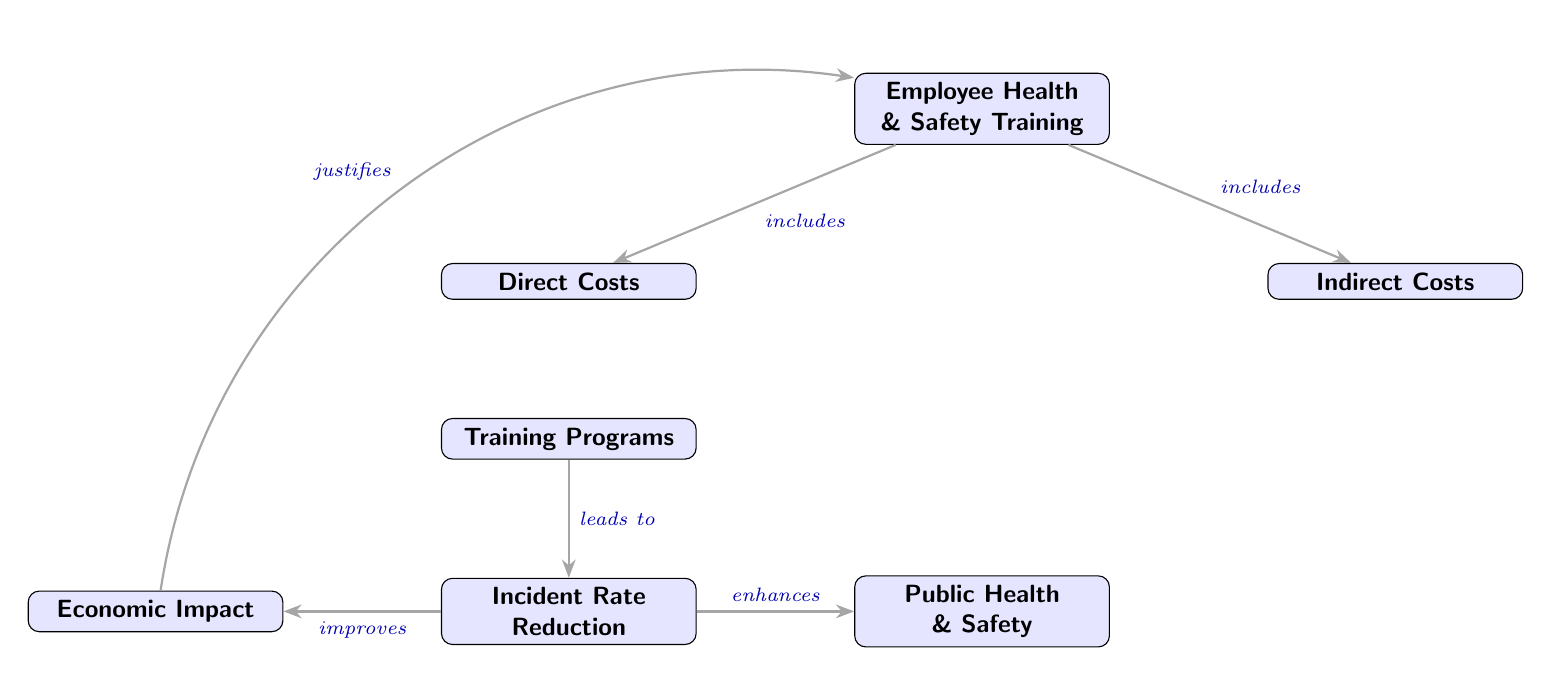What is the first node in the diagram? The first node in the diagram is labeled "Employee Health & Safety Training." This is the starting point from which all other elements are connected.
Answer: Employee Health & Safety Training How many total nodes are there in the diagram? By counting each distinct box within the diagram, we see there are seven nodes: one at the top and six below it.
Answer: 7 What types of costs are represented in relation to Employee Health & Safety Training? The diagram includes two types of costs: Direct Costs and Indirect Costs. These are specifically mentioned as part of the connections stemming from the main training node.
Answer: Direct Costs and Indirect Costs Which node leads to the Incident Rate Reduction? The node that leads to "Incident Rate Reduction" is "Training Programs." According to the arrows, "Training Programs" provides the necessary input for achieving a reduction in the incident rate.
Answer: Training Programs What improvements are linked to the Incident Rate Reduction? The "Incident Rate Reduction" leads to two improvements: "Economic Impact" and "Public Health & Safety." These improvements demonstrate the benefits of reducing incidents in the workplace.
Answer: Economic Impact and Public Health & Safety How do Direct Costs relate to Training Programs? Direct Costs contribute to Training Programs by including expenses such as material costs and instructor fees, as indicated by the arrow connecting these nodes along with the related quote.
Answer: material costs, instructor fees What relationship is implied between Economic Impact and Employee Health & Safety Training? The diagram shows that Economic Impact is justified by the Employee Health & Safety Training through a feedback loop, illustrating that the training programs lead to improved economic outcomes.
Answer: justifies What effects does Training Programs produce besides reducing the incident rate? Aside from reducing the incident rate, "Training Programs" also have implications for both Direct Costs and Indirect Costs, indicating that the training is related to various expenses associated with workplace safety.
Answer: Direct Costs and Indirect Costs What specific examples are given under Indirect Costs? The specific example provided under Indirect Costs is "lost work hours," emphasizing the impact of workplace incidents on employee productivity and availability.
Answer: lost work hours 